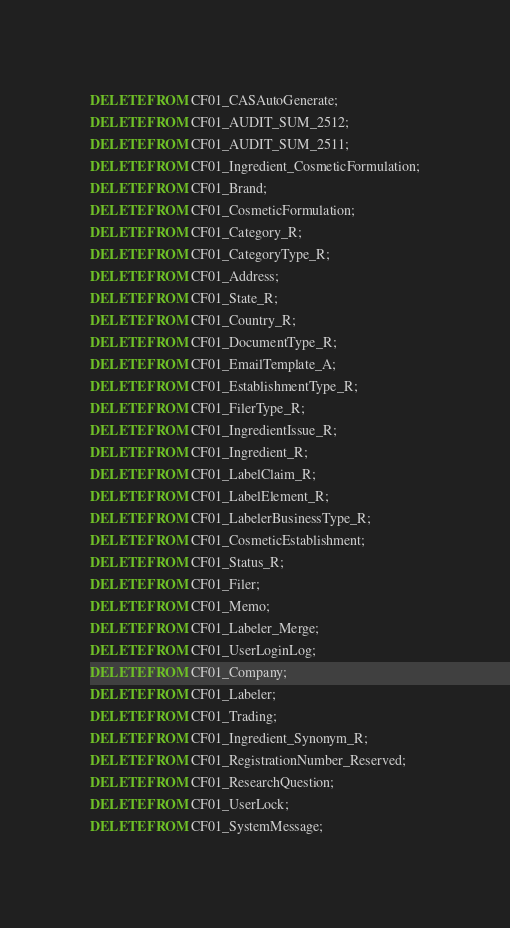<code> <loc_0><loc_0><loc_500><loc_500><_SQL_>DELETE FROM CF01_CASAutoGenerate;
DELETE FROM CF01_AUDIT_SUM_2512;
DELETE FROM CF01_AUDIT_SUM_2511;
DELETE FROM CF01_Ingredient_CosmeticFormulation;
DELETE FROM CF01_Brand;
DELETE FROM CF01_CosmeticFormulation;
DELETE FROM CF01_Category_R;
DELETE FROM CF01_CategoryType_R;
DELETE FROM CF01_Address;
DELETE FROM CF01_State_R;
DELETE FROM CF01_Country_R;
DELETE FROM CF01_DocumentType_R;
DELETE FROM CF01_EmailTemplate_A;
DELETE FROM CF01_EstablishmentType_R;
DELETE FROM CF01_FilerType_R;
DELETE FROM CF01_IngredientIssue_R;
DELETE FROM CF01_Ingredient_R;
DELETE FROM CF01_LabelClaim_R;
DELETE FROM CF01_LabelElement_R;
DELETE FROM CF01_LabelerBusinessType_R;
DELETE FROM CF01_CosmeticEstablishment;
DELETE FROM CF01_Status_R;
DELETE FROM CF01_Filer;
DELETE FROM CF01_Memo;
DELETE FROM CF01_Labeler_Merge;
DELETE FROM CF01_UserLoginLog;
DELETE FROM CF01_Company;
DELETE FROM CF01_Labeler;
DELETE FROM CF01_Trading;
DELETE FROM CF01_Ingredient_Synonym_R;
DELETE FROM CF01_RegistrationNumber_Reserved;
DELETE FROM CF01_ResearchQuestion;
DELETE FROM CF01_UserLock;
DELETE FROM CF01_SystemMessage;
</code> 